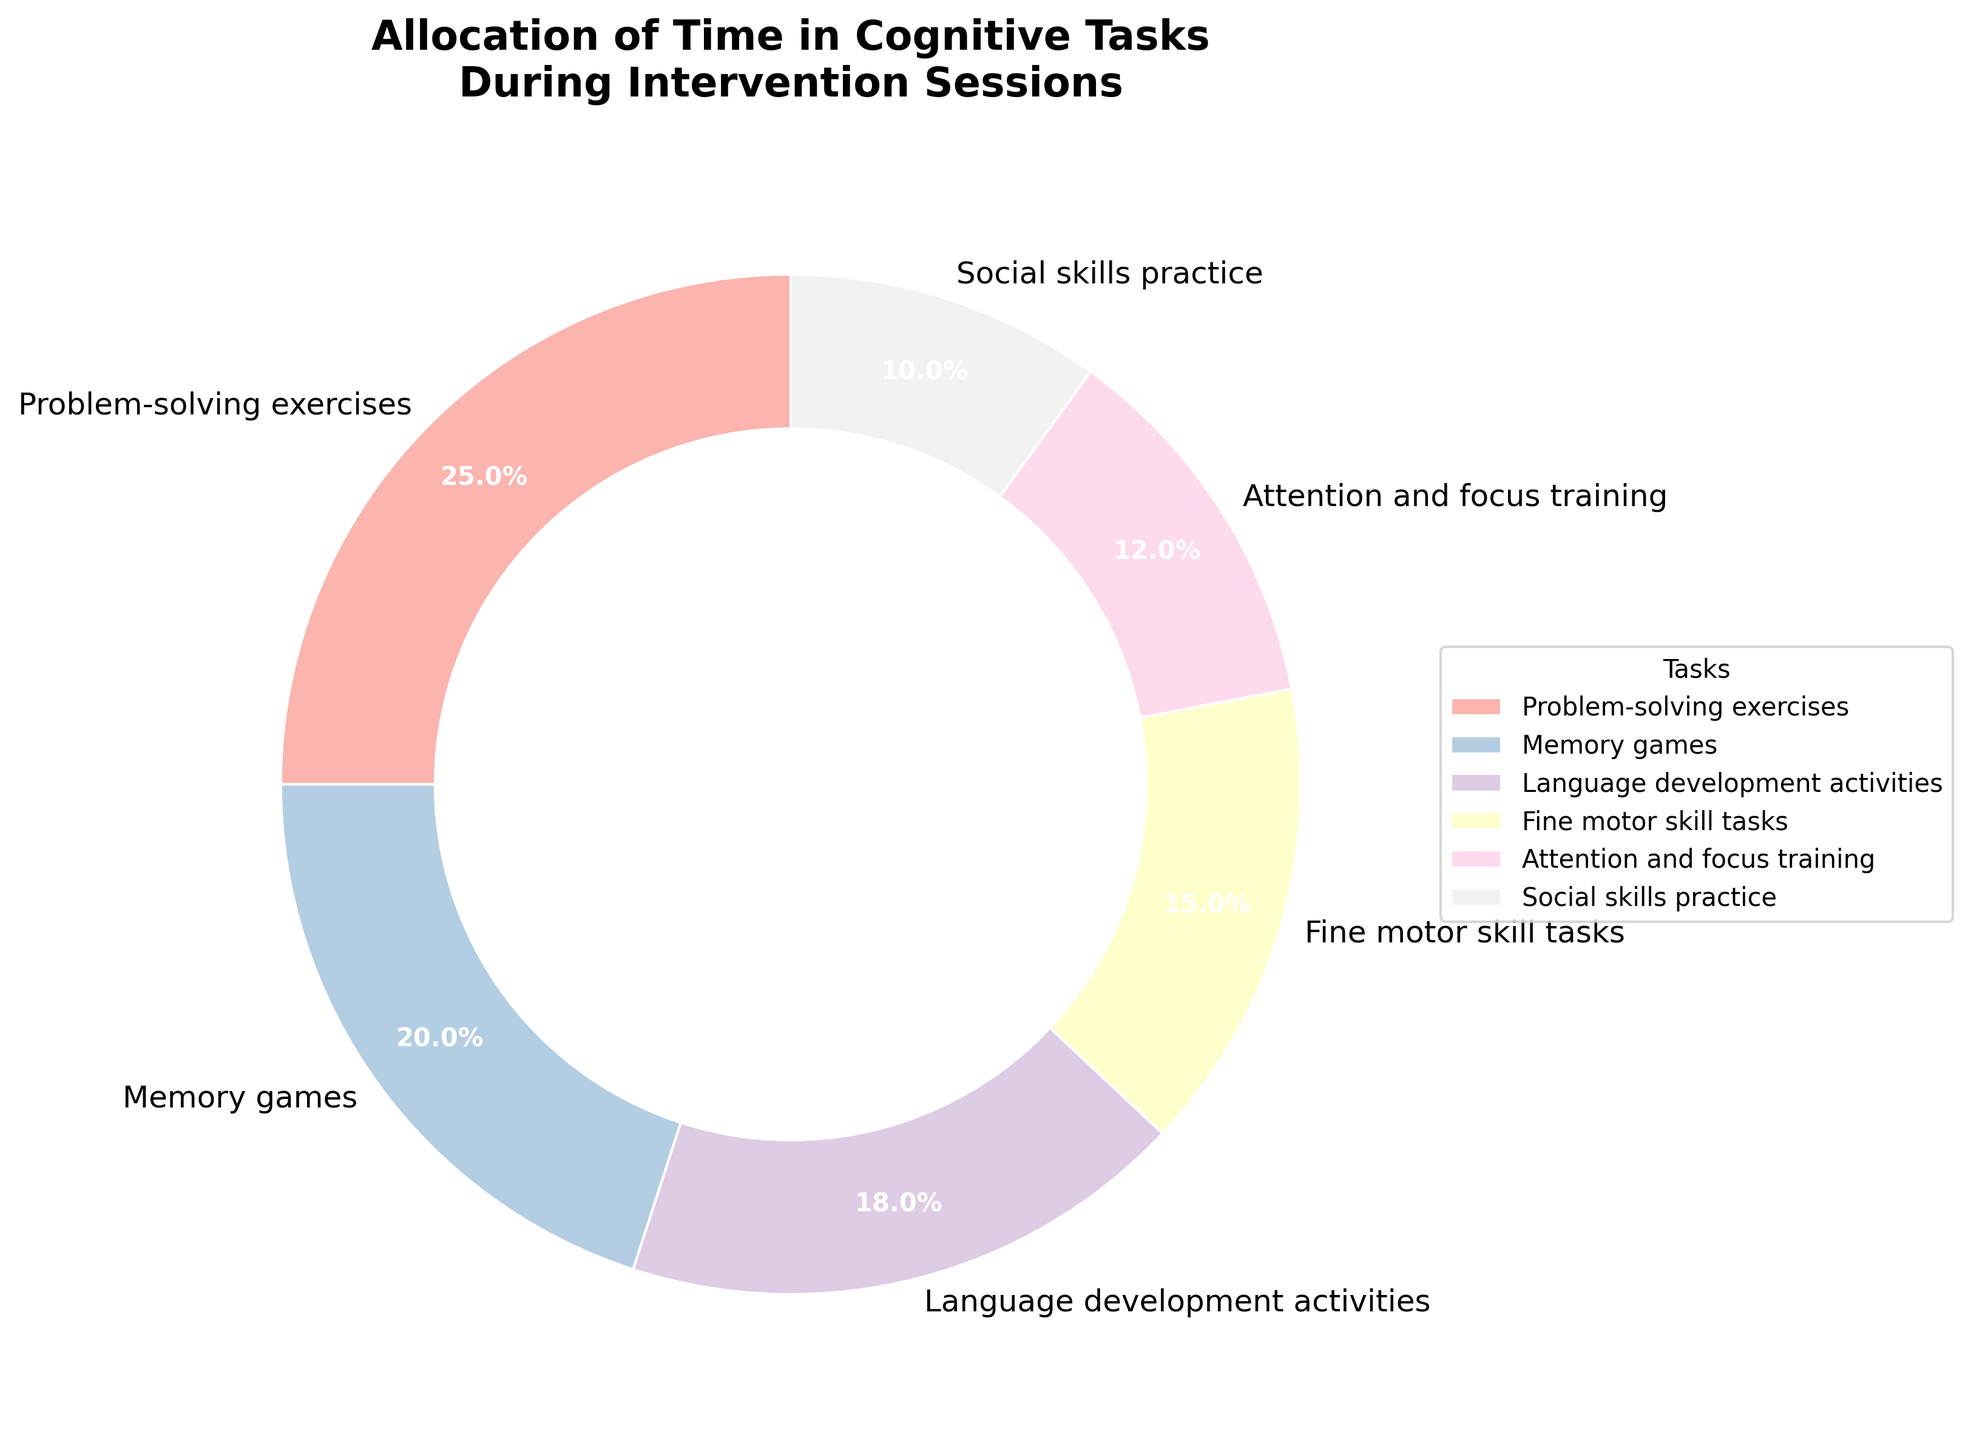What's the most time-consuming task during intervention sessions? The task with the highest percentage represents the most time-consuming task. According to the pie chart, Problem-solving exercises have the highest percentage at 25%.
Answer: Problem-solving exercises What's the least time-consuming task during intervention sessions? The task with the lowest percentage represents the least time-consuming task. According to the pie chart, Social skills practice has the lowest percentage at 10%.
Answer: Social skills practice How much more time is spent on Problem-solving exercises compared to Social skills practice? The percentage of time spent on Problem-solving exercises is 25%, and for Social skills practice, it is 10%. The difference is 25% - 10% = 15%.
Answer: 15% What is the combined percentage of time spent on Fine motor skill tasks and Attention and focus training? The percentage of time spent on Fine motor skill tasks is 15%, and for Attention and focus training, it is 12%. The combined percentage is 15% + 12% = 27%.
Answer: 27% Which two tasks together occupy exactly 30% of the time? By examining the pie chart, Memory games (20%) and Social skills practice (10%) together occupy 20% + 10% = 30%.
Answer: Memory games and Social skills practice Among Memory games, Language development activities, and Social skills practice, which task uses more time? Comparing their percentages: Memory games (20%), Language development activities (18%), Social skills practice (10%). Memory games uses the most time at 20%.
Answer: Memory games What's the difference in percentage between the second most time-consuming task and the fourth most time-consuming task? The second most time-consuming task is Memory games (20%), and the fourth is Fine motor skill tasks (15%). The difference is 20% - 15% = 5%.
Answer: 5% How much percentage of the time is spent on tasks that are not directly cognitive (motor skill-related tasks)? The only motor skill-related task listed is Fine motor skill tasks at 15%. Thus, the time spent on non-cognitive tasks is 100% - 15% = 85%.
Answer: 85% What's the average percentage of time allocated to Language development activities, Fine motor skill tasks, and Attention and focus training? The percentages are 18%, 15%, and 12% respectively. The average is (18% + 15% + 12%) / 3 = 15%.
Answer: 15% 